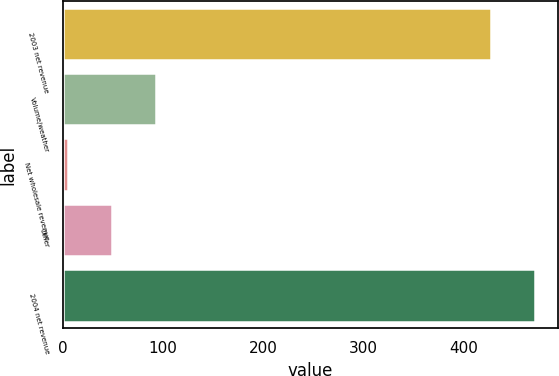<chart> <loc_0><loc_0><loc_500><loc_500><bar_chart><fcel>2003 net revenue<fcel>Volume/weather<fcel>Net wholesale revenue<fcel>Other<fcel>2004 net revenue<nl><fcel>426.6<fcel>92.7<fcel>5<fcel>48.85<fcel>470.45<nl></chart> 